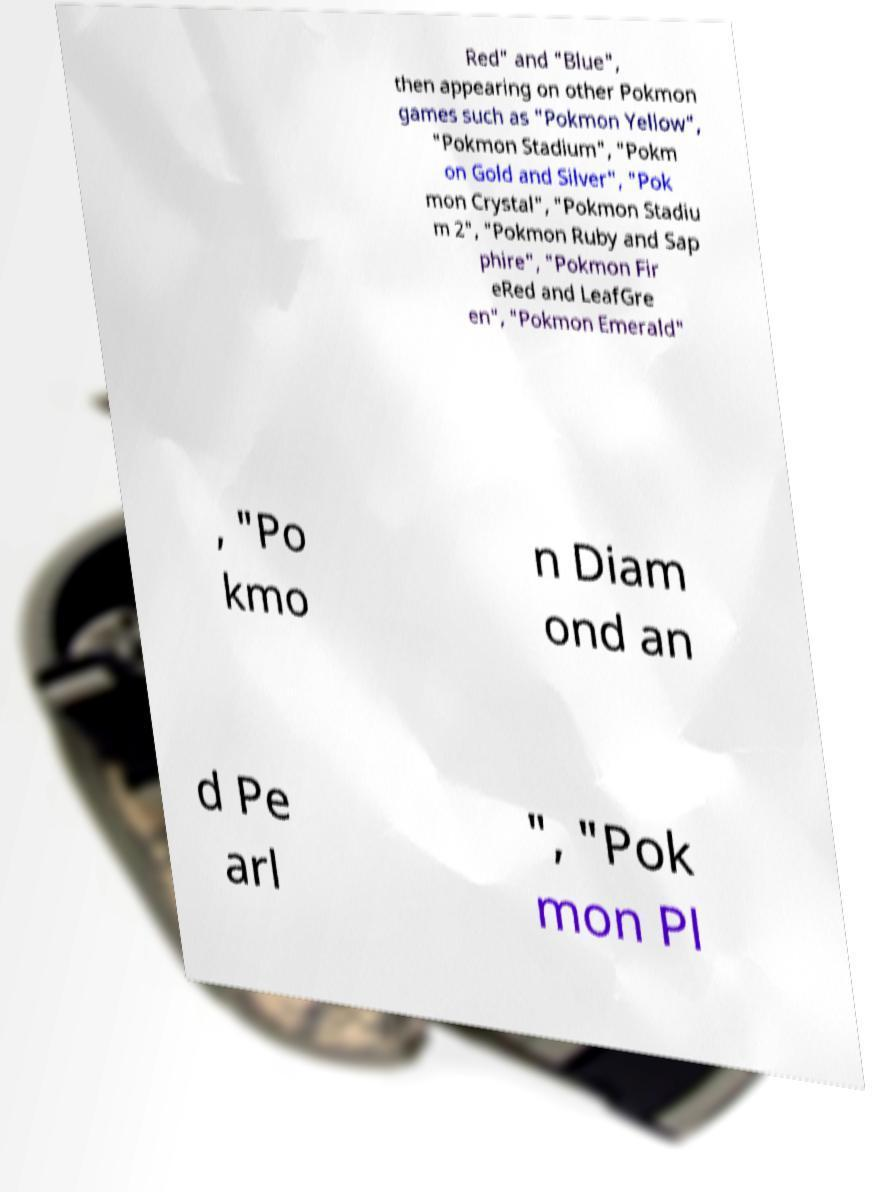Could you extract and type out the text from this image? Red" and "Blue", then appearing on other Pokmon games such as "Pokmon Yellow", "Pokmon Stadium", "Pokm on Gold and Silver", "Pok mon Crystal", "Pokmon Stadiu m 2", "Pokmon Ruby and Sap phire", "Pokmon Fir eRed and LeafGre en", "Pokmon Emerald" , "Po kmo n Diam ond an d Pe arl ", "Pok mon Pl 